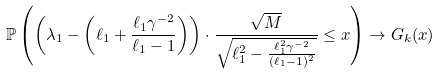<formula> <loc_0><loc_0><loc_500><loc_500>\mathbb { P } \left ( \left ( \lambda _ { 1 } - \left ( \ell _ { 1 } + \frac { \ell _ { 1 } \gamma ^ { - 2 } } { \ell _ { 1 } - 1 } \right ) \right ) \cdot \frac { \sqrt { M } } { \sqrt { \ell _ { 1 } ^ { 2 } - \frac { \ell _ { 1 } ^ { 2 } \gamma ^ { - 2 } } { ( \ell _ { 1 } - 1 ) ^ { 2 } } } } \leq x \right ) \to G _ { k } ( x )</formula> 